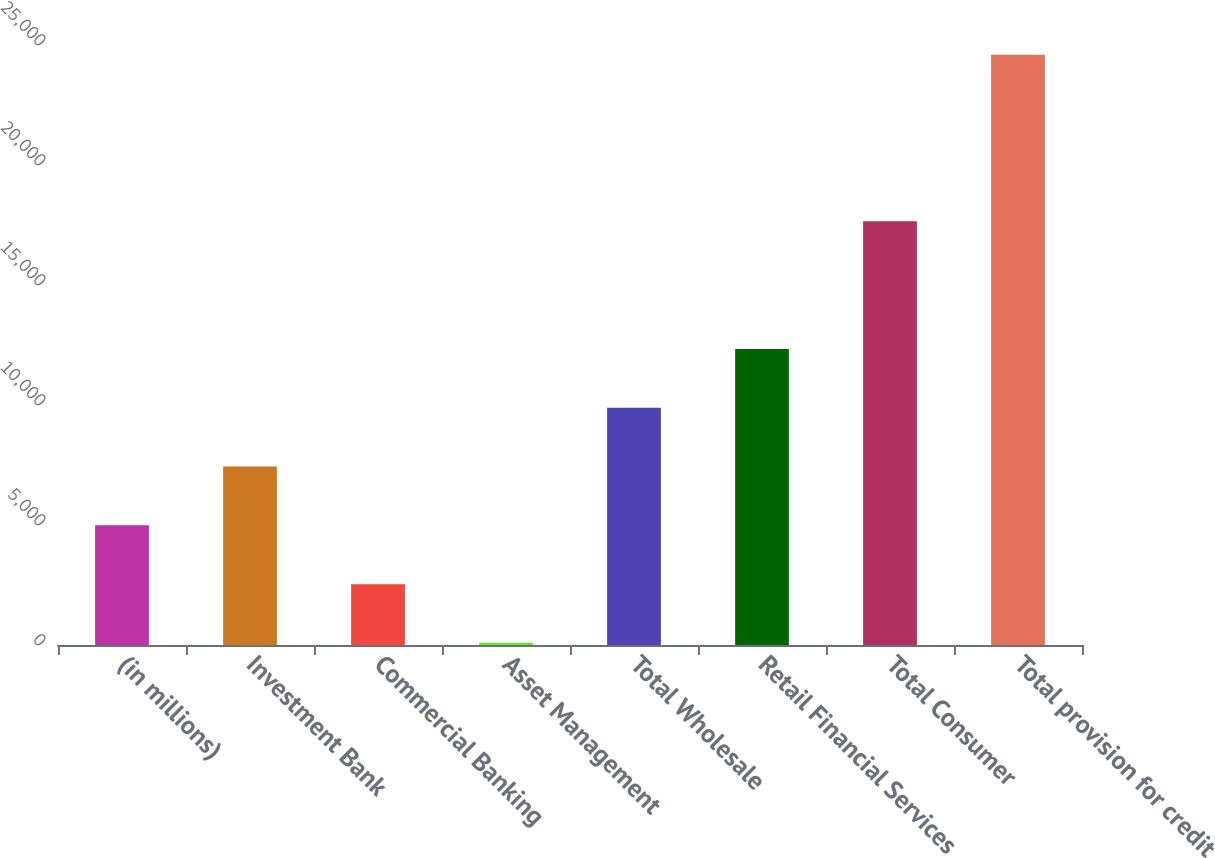Convert chart. <chart><loc_0><loc_0><loc_500><loc_500><bar_chart><fcel>(in millions)<fcel>Investment Bank<fcel>Commercial Banking<fcel>Asset Management<fcel>Total Wholesale<fcel>Retail Financial Services<fcel>Total Consumer<fcel>Total provision for credit<nl><fcel>4986.2<fcel>7436.8<fcel>2535.6<fcel>85<fcel>9887.4<fcel>12338<fcel>17652<fcel>24591<nl></chart> 